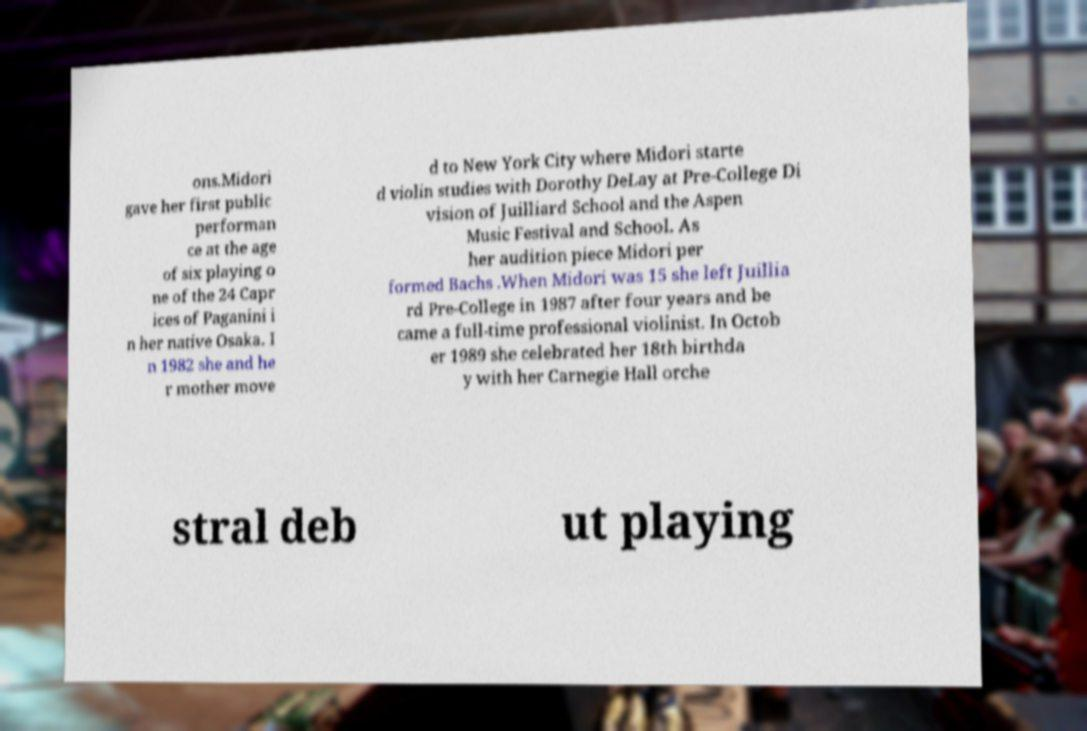Can you accurately transcribe the text from the provided image for me? ons.Midori gave her first public performan ce at the age of six playing o ne of the 24 Capr ices of Paganini i n her native Osaka. I n 1982 she and he r mother move d to New York City where Midori starte d violin studies with Dorothy DeLay at Pre-College Di vision of Juilliard School and the Aspen Music Festival and School. As her audition piece Midori per formed Bachs .When Midori was 15 she left Juillia rd Pre-College in 1987 after four years and be came a full-time professional violinist. In Octob er 1989 she celebrated her 18th birthda y with her Carnegie Hall orche stral deb ut playing 